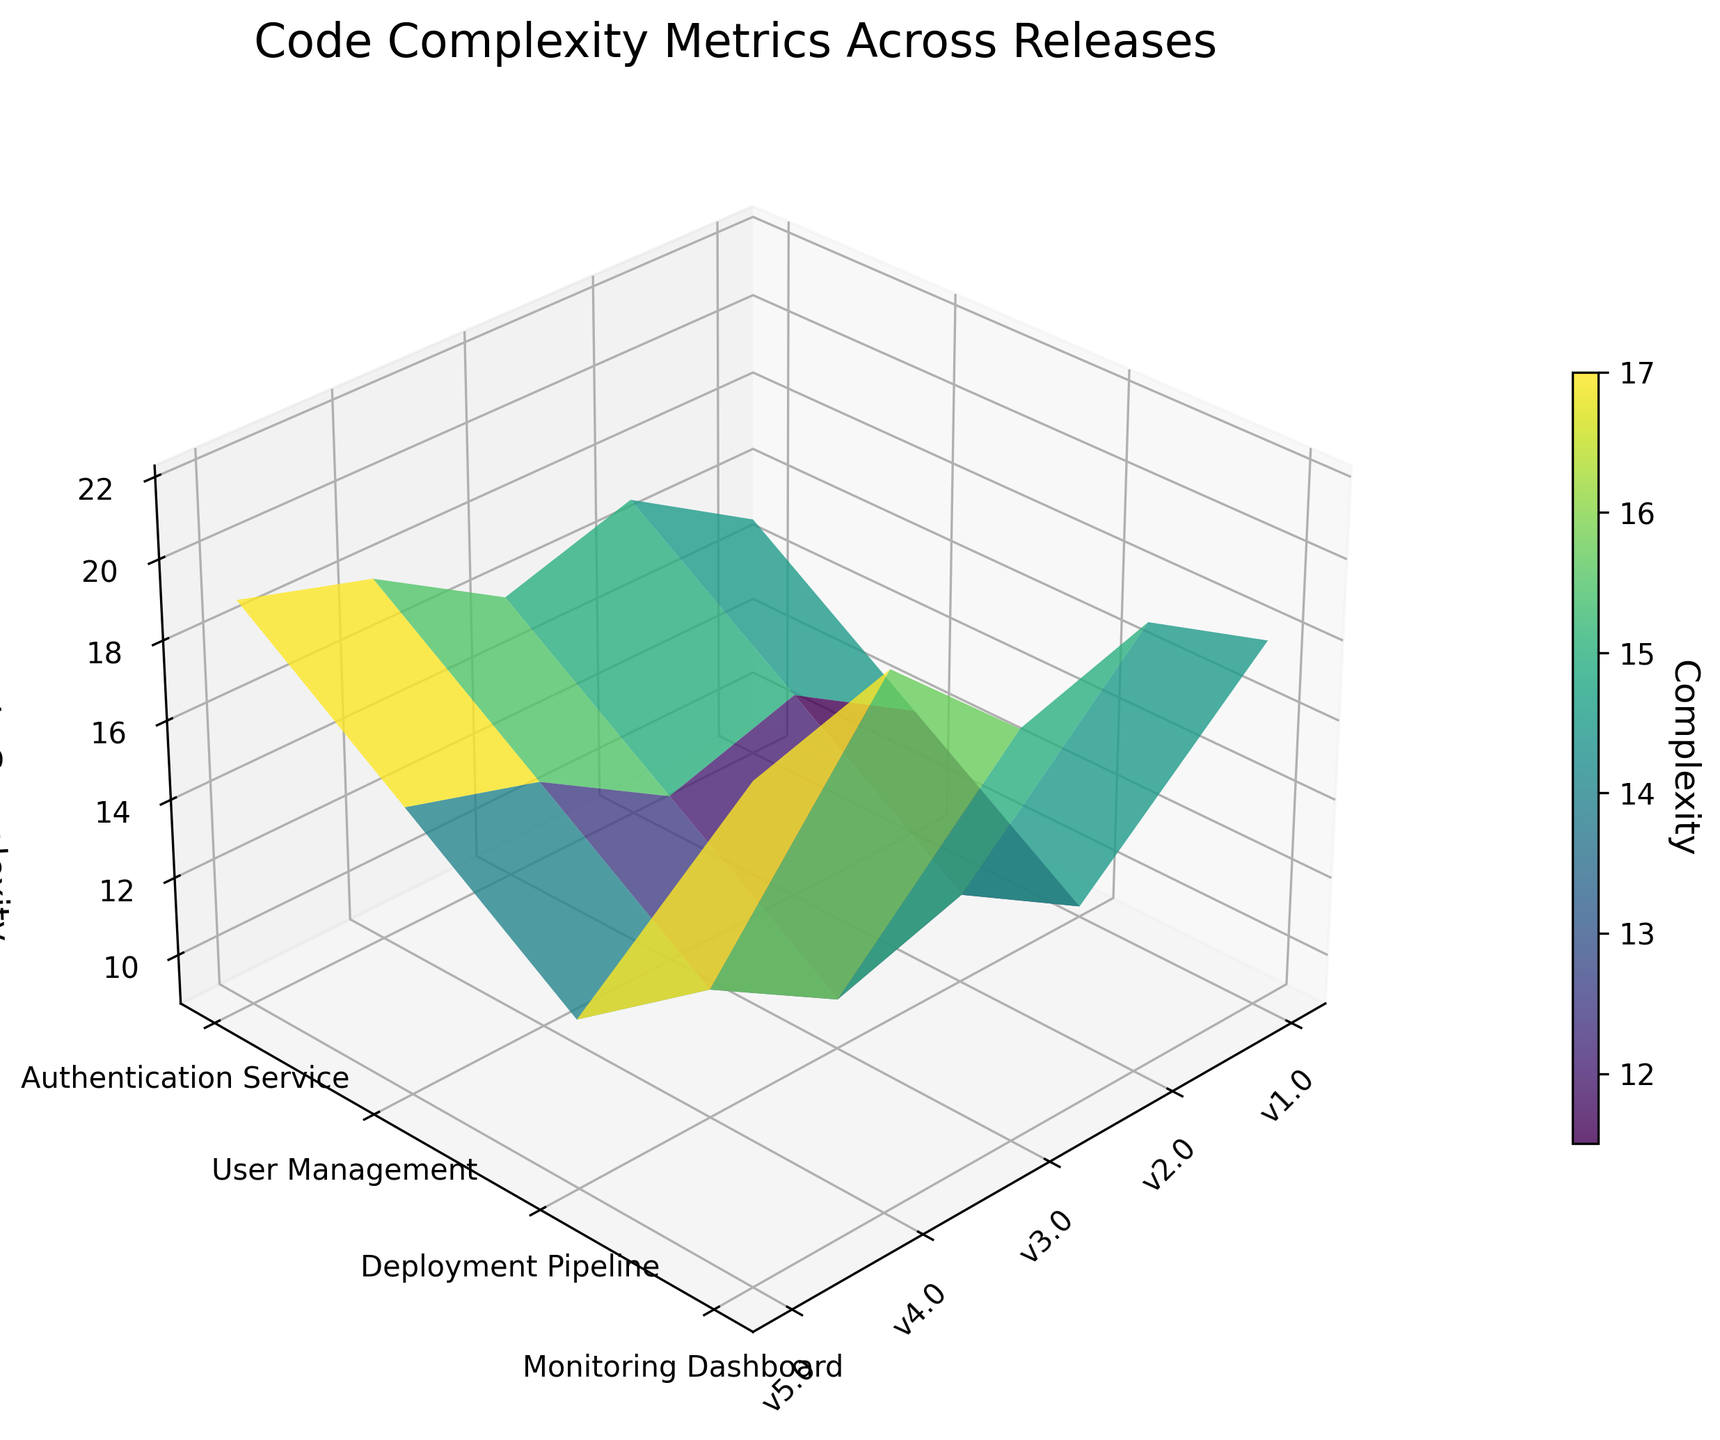What is the title of the plot? The title is located at the top of the plot and summarizes the data being visualized.
Answer: Code Complexity Metrics Across Releases Which component has the highest cyclomatic complexity in release v5.0? Look at the v5.0 release (x-axis) and find the point on the surface plot with the highest z-value (cyclomatic complexity) for each component. Compare the values to find the maximum.
Answer: User Management How many components are displayed in the plot? The plot shows components on the y-axis. Count the number of unique ticks/labels.
Answer: 4 What is the cyclomatic complexity of the Deployment Pipeline in release v3.0? Find the appropriate location on the x-axis for v3.0 and on the y-axis for Deployment Pipeline, then identify the z-value (cyclomatic complexity) at this intersection.
Answer: 13 Which release had the lowest average cyclomatic complexity across all components? Calculate the average z-values for each release by summing the values and dividing by the number of components. Compare these averages to determine the lowest one.
Answer: v1.0 How does the complexity of the Monitoring Dashboard change from v1.0 to v5.0? Track the z-values (cyclomatic complexity) of the Monitoring Dashboard across the x-axis from v1.0 to v5.0 and observe the changes.
Answer: Increases from 9 to 13 Compare the cyclomatic complexity of the Authentication Service and the Deployment Pipeline in release v4.0. Which is higher? Locate v4.0 on the x-axis, then find the z-values for Authentication Service and Deployment Pipeline. Compare these values.
Answer: Authentication Service What is the general trend of complexity for the User Management component over multiple releases? Examine the z-values for User Management across the x-axis from the earliest to the most recent release to determine any upward, downward, or stable trends.
Answer: Increasing trend What is the difference in cyclomatic complexity between the Authentication Service in v2.0 and v3.0? Identify the z-values for Authentication Service in v2.0 and v3.0, then subtract the v2.0 value from the v3.0 value to find the difference.
Answer: -1 Which component shows the least variability in cyclomatic complexity across all releases? Assess the z-values for each component across all releases and determine the one with the smallest range (difference between highest and lowest values).
Answer: Monitoring Dashboard 